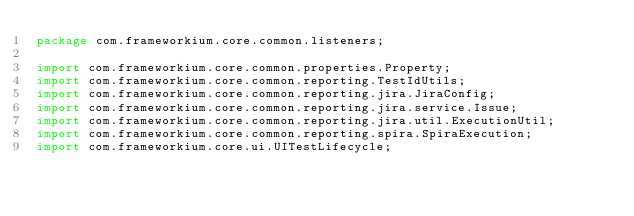Convert code to text. <code><loc_0><loc_0><loc_500><loc_500><_Java_>package com.frameworkium.core.common.listeners;

import com.frameworkium.core.common.properties.Property;
import com.frameworkium.core.common.reporting.TestIdUtils;
import com.frameworkium.core.common.reporting.jira.JiraConfig;
import com.frameworkium.core.common.reporting.jira.service.Issue;
import com.frameworkium.core.common.reporting.jira.util.ExecutionUtil;
import com.frameworkium.core.common.reporting.spira.SpiraExecution;
import com.frameworkium.core.ui.UITestLifecycle;</code> 